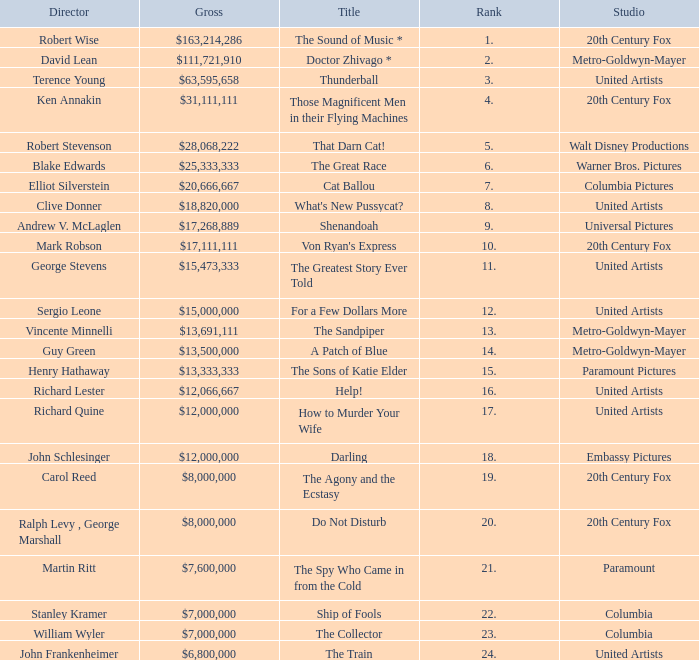What is the highest Rank, when Director is "Henry Hathaway"? 15.0. 